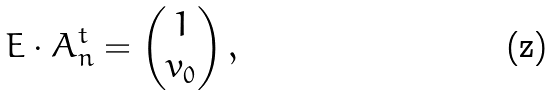Convert formula to latex. <formula><loc_0><loc_0><loc_500><loc_500>E \cdot A _ { n } ^ { t } = \begin{pmatrix} 1 \\ v _ { 0 } \end{pmatrix} ,</formula> 